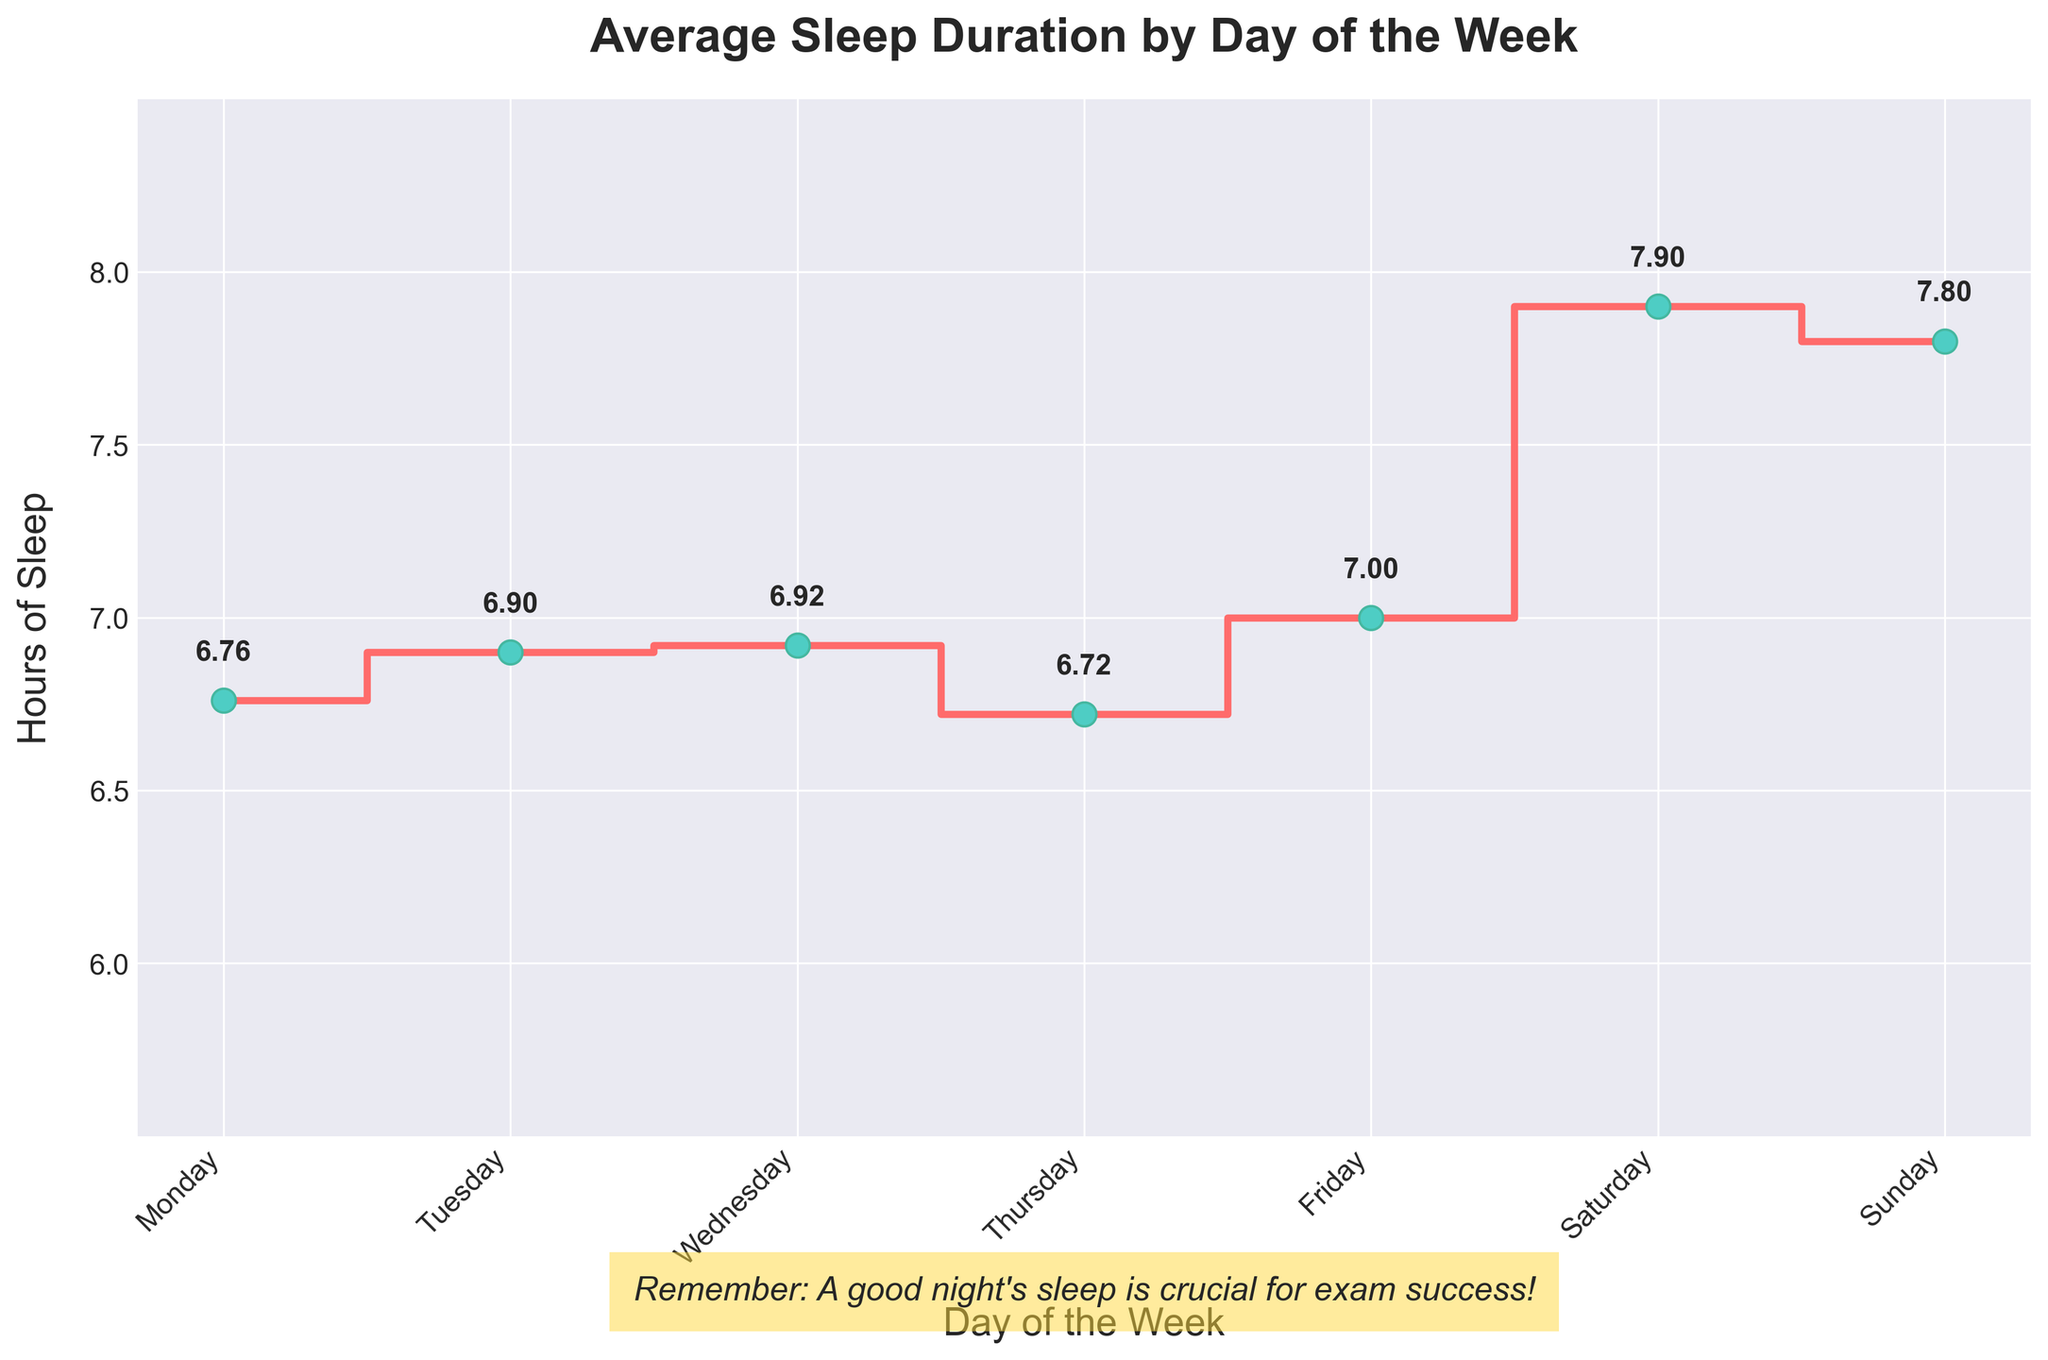what is the title of the plot? The title is displayed at the top of the figure, above the plot area.
Answer: Average Sleep Duration by Day of the Week What is the average number of hours of sleep on Wednesday? Locate the "Wednesday" position on the x-axis and find the corresponding value on the y-axis.
Answer: 6.92 Which day has the highest average sleep duration? Compare the values labeled above each day and identify the highest value.
Answer: Saturday How does the average sleep on Friday compare to Monday? Find and compare the average sleep values for Friday and Monday by looking at the y-axis values they correspond to.
Answer: Friday is higher What's the average sleep duration for the whole week? Sum the average sleep durations for each day and divide by the number of days (7).
Answer: 7.07 On which day is the average sleep duration closest to 7 hours? Identify the days with sleep durations and determine which is nearest to 7.
Answer: Sunday What is the difference in average sleep duration between the weekend (Saturday and Sunday) and Monday? Calculate the average for Saturday and Sunday, find the difference with Monday's average sleep duration.
Answer: 7.8 - 6.76 = 1.04 Which days have an average sleep duration of less than 7 hours? Locate the days on the x-axis with average sleep durations below 7 on the y-axis.
Answer: Monday, Tuesday, Wednesday, Thursday Does any day have an average sleep duration above 8 hours? Check if any day’s average sleep value surpasses 8 by observing the y-axis labels.
Answer: No Between Tuesday and Thursday, on which day do students get more sleep and by how much? Compare Tuesday's and Thursday's average sleep values and calculate the difference.
Answer: Tuesday, by 0.25 hours 